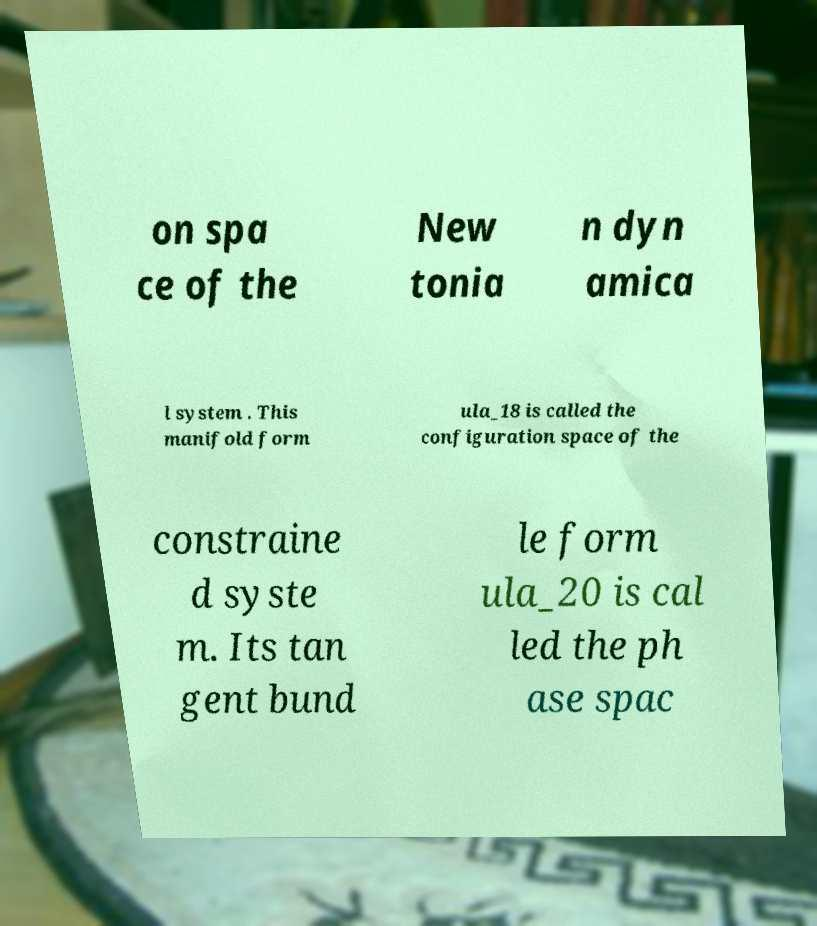Please identify and transcribe the text found in this image. on spa ce of the New tonia n dyn amica l system . This manifold form ula_18 is called the configuration space of the constraine d syste m. Its tan gent bund le form ula_20 is cal led the ph ase spac 